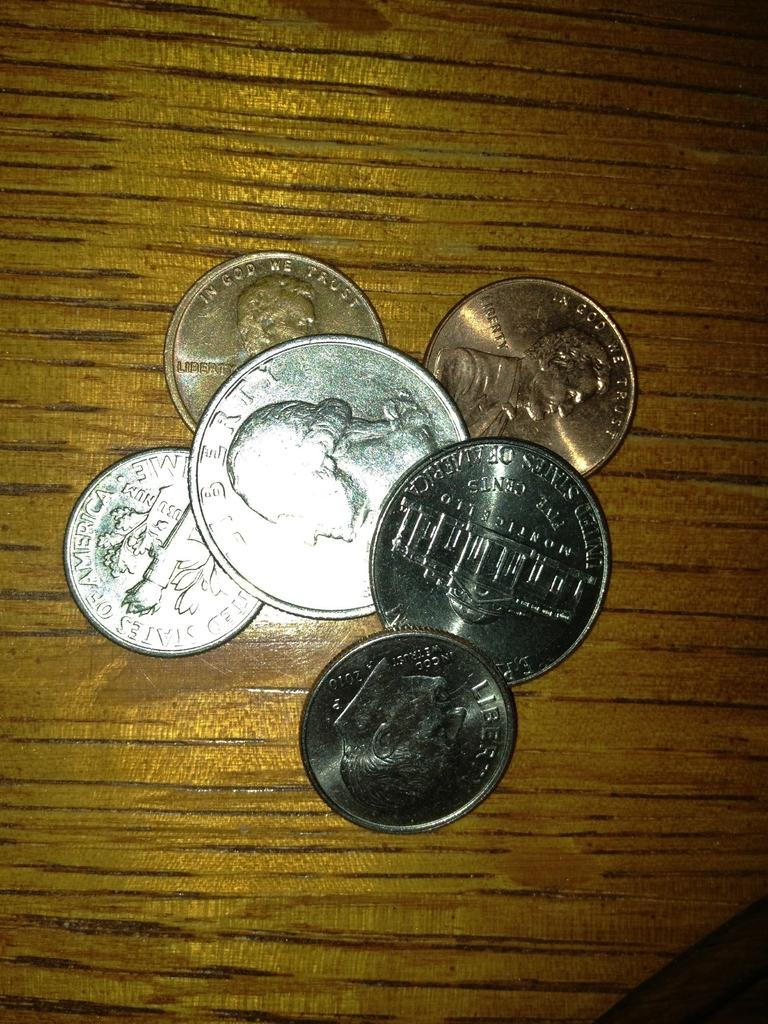<image>
Share a concise interpretation of the image provided. Six US coins, including a five cent and a dime coin, are piled on a wooden surface. 